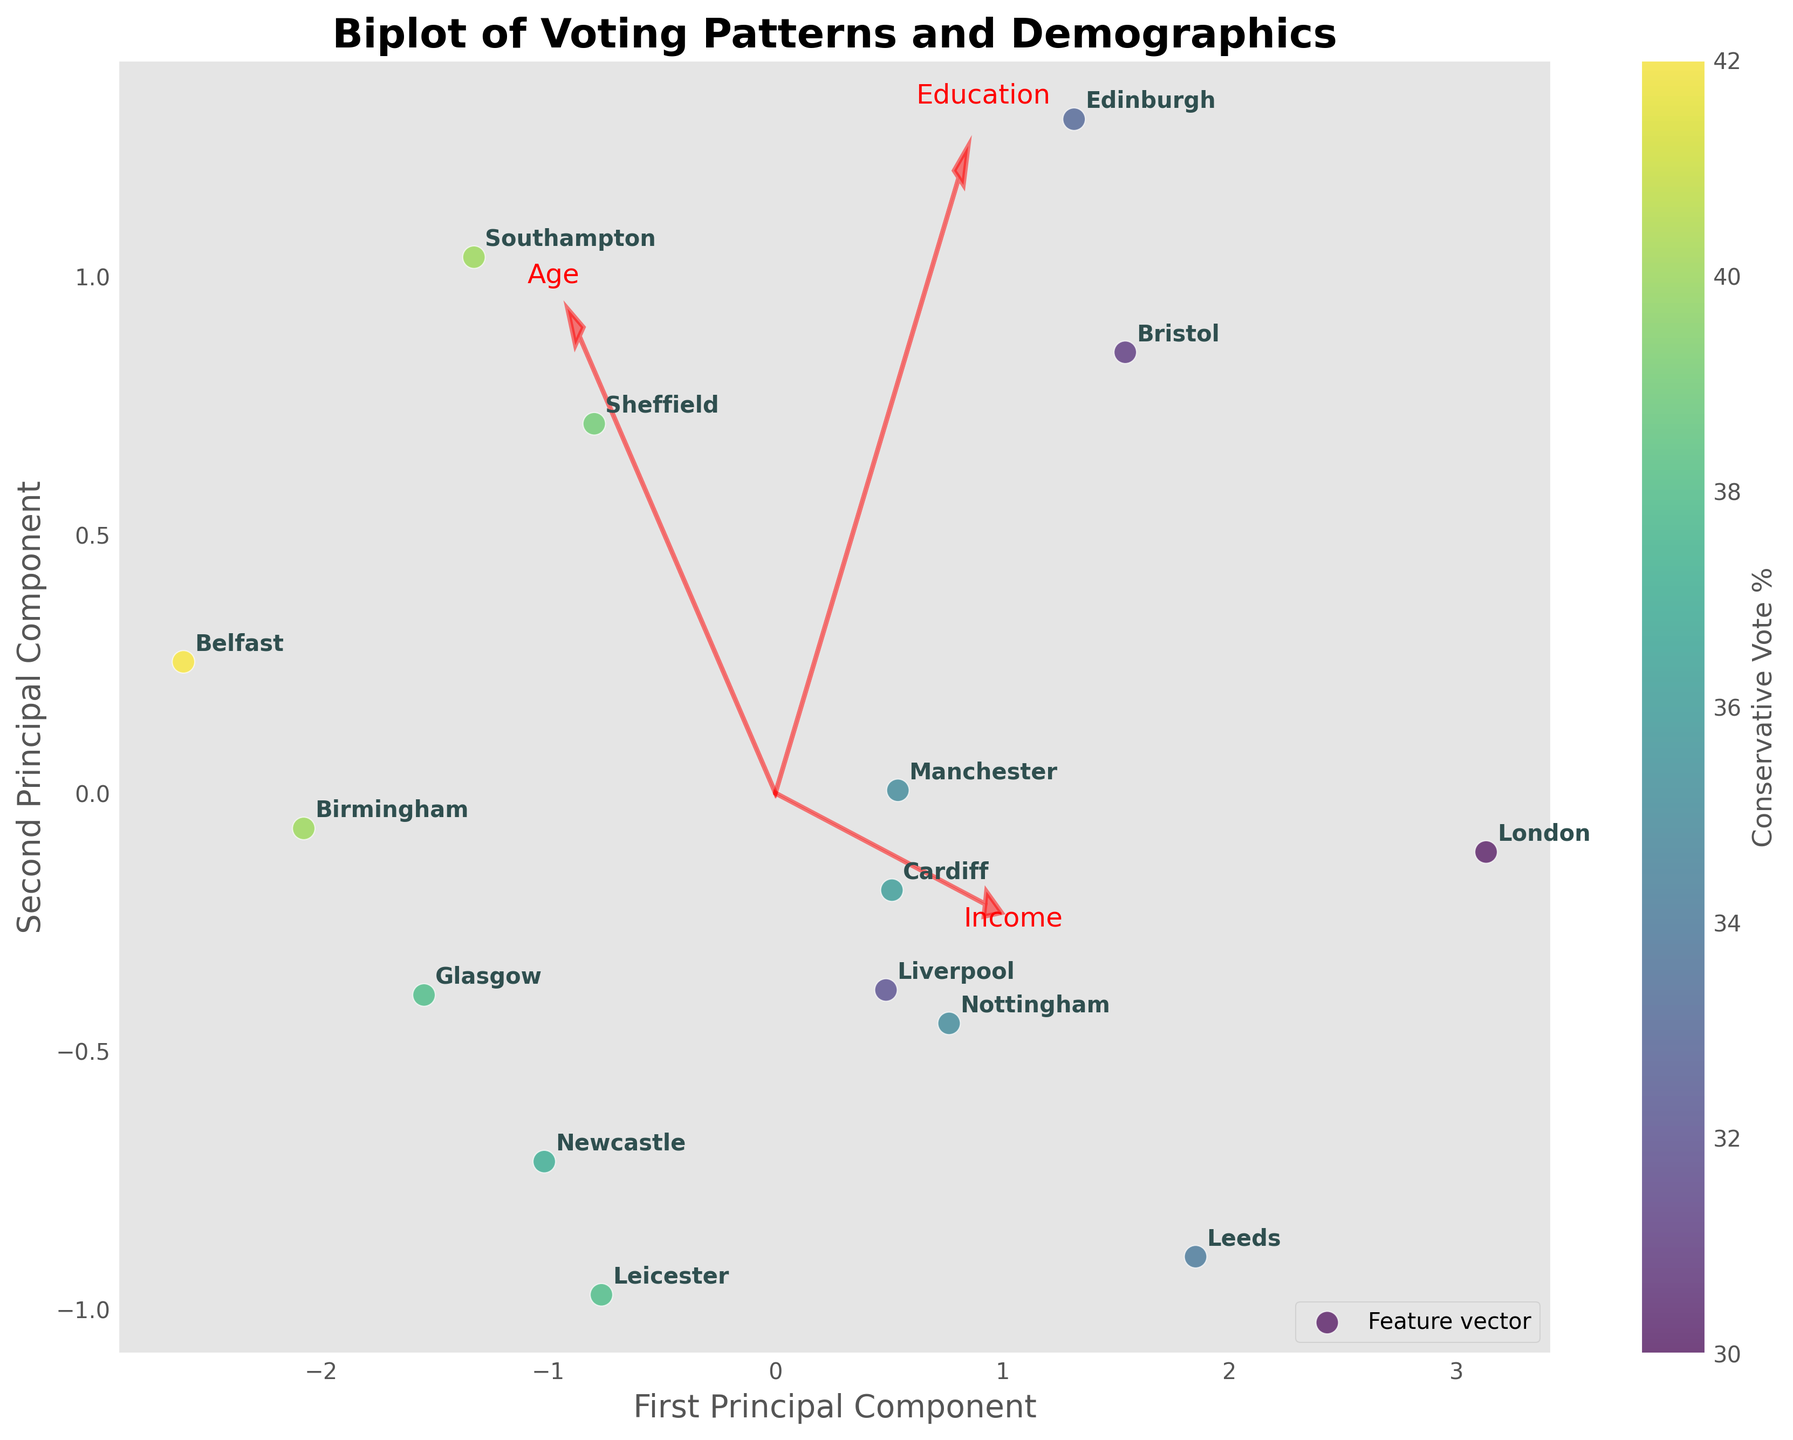What is the title of the plot? The title of the plot is positioned at the top of the figure. It reads "Biplot of Voting Patterns and Demographics".
Answer: Biplot of Voting Patterns and Demographics How many data points are there in the plot? The plot shows individual points for each region listed in the data. By counting these points, we observe there are 15 data points corresponding to the number of regions.
Answer: 15 Which region has the highest Conservative vote percentage as indicated by the color of the data points? The color bar on the right indicates the Conservative Vote percentage. The point with the darkest color represents the region with the highest Conservative vote percentage. Observing the plot, Belfast appears to have the darkest color.
Answer: Belfast How are the age, income, and education levels represented in the plot? Age, income, and education levels are represented by feature vectors (arrows in red) emanating from the origin (0,0) of the plot. Each vector is labeled with its corresponding demographic characteristic.
Answer: By feature vectors Which axis is the First Principal Component and which one is the Second Principal Component? The labels on the axes provide this information. The horizontal axis is labeled 'First Principal Component', and the vertical axis is labeled 'Second Principal Component'.
Answer: The horizontal axis is the First Principal Component and the vertical axis is the Second Principal Component What characteristics are most strongly associated with the first principal component? Feature vectors indicate the association. The arrow for age points strongly along the horizontal (first principal component) axis, suggesting that age is the most strongly associated characteristic with this component.
Answer: Age Do higher income levels appear to correlate with higher or lower Conservative votes based on the data points’ colors and positions? To find this, observe points with higher income levels (more to the right if income vector points right) and check their colors. The lightness/darkness of the points corresponds to Conservative vote percentages. Higher income levels tend to correlate with higher Conservative votes as darker points (indicating higher Conservative votes) are seen more towards higher-income regions.
Answer: Higher Which two regions appear closest together on the plot suggesting similar voting patterns and demographics? By observing the plot, the regions whose points are closest together suggest similarity. Cardiff and Nottingham appear very close together, indicating they have similar voting patterns and demographics.
Answer: Cardiff and Nottingham What does the length of the feature vector arrows represent in the context of the biplot? The length of the feature vector arrows represents the relative importance or contribution of each demographic characteristic to the variability explained by the principal components. Longer vectors suggest a larger contribution.
Answer: Relative importance of the demographic characteristic Which region is most similar to Manchester based on voting patterns and demographic characteristics? By looking at the proximity of points, identify the regions closest to Manchester. Liverpool and Nottingham are quite near to Manchester on the plot, suggesting they have similar voting patterns and demographic characteristics.
Answer: Liverpool and Nottingham 